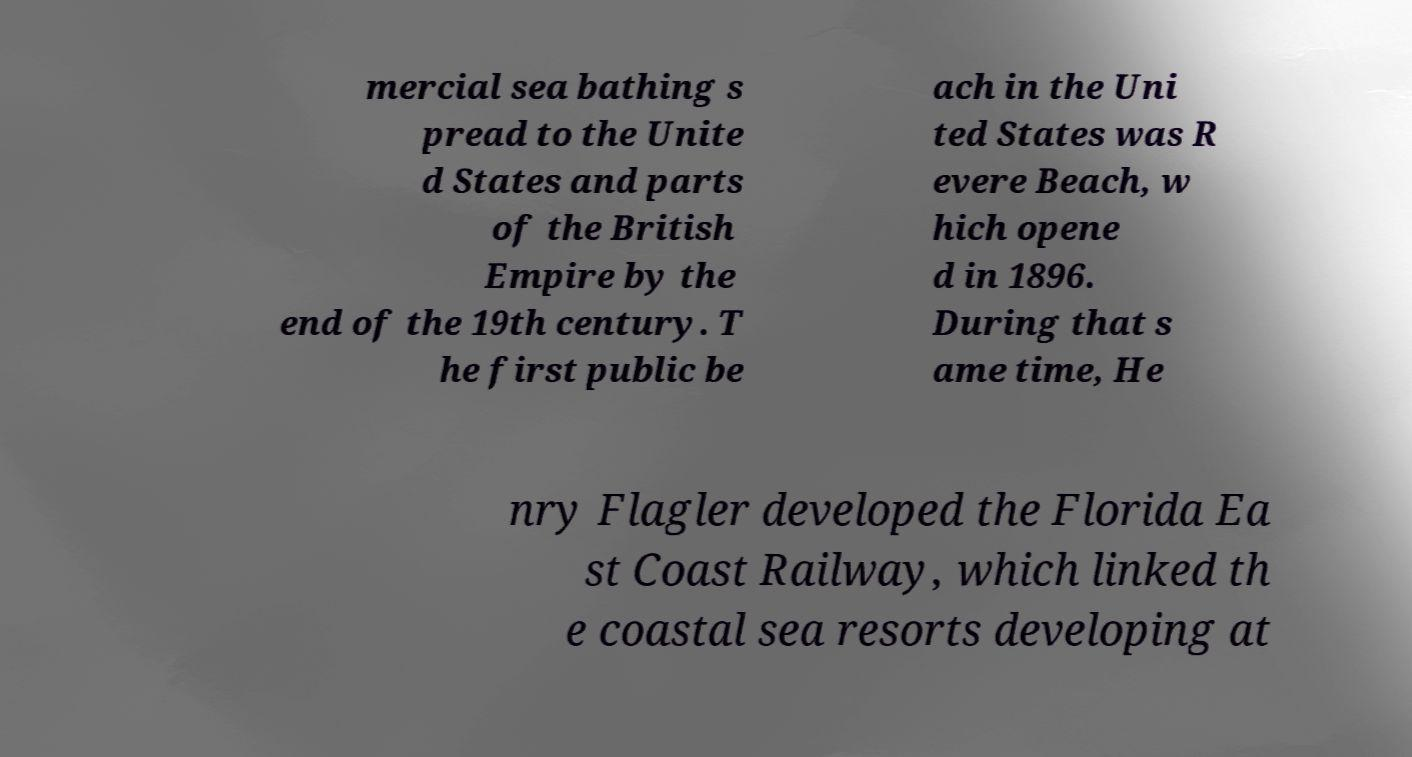Please identify and transcribe the text found in this image. mercial sea bathing s pread to the Unite d States and parts of the British Empire by the end of the 19th century. T he first public be ach in the Uni ted States was R evere Beach, w hich opene d in 1896. During that s ame time, He nry Flagler developed the Florida Ea st Coast Railway, which linked th e coastal sea resorts developing at 